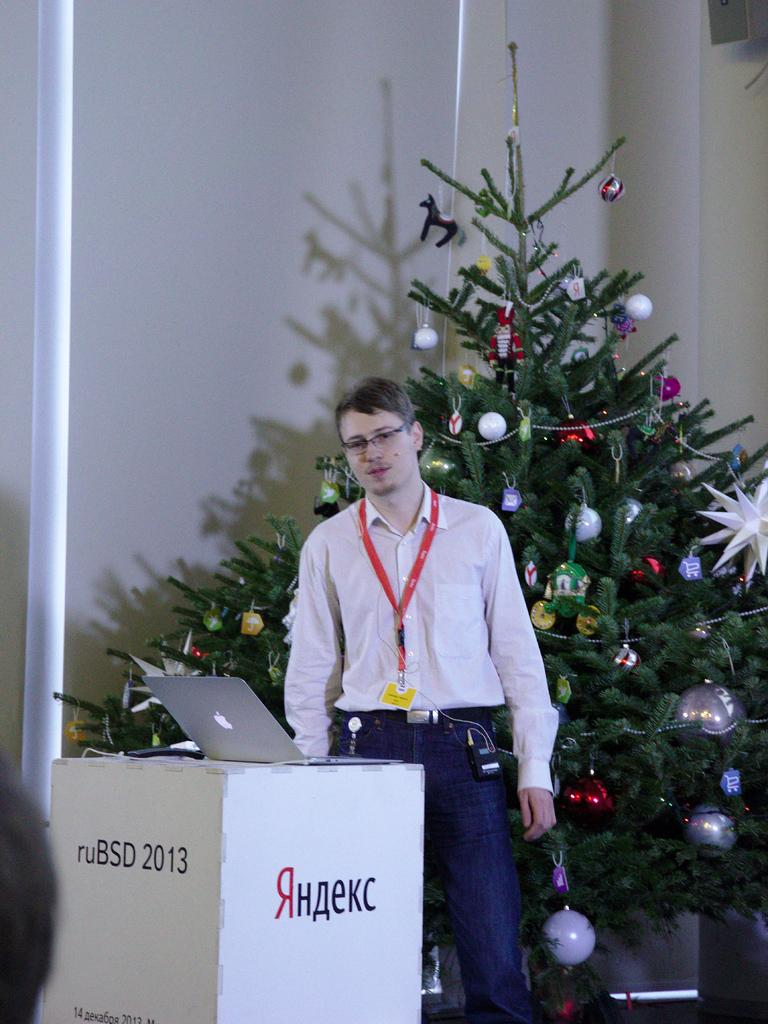<image>
Share a concise interpretation of the image provided. A man stands in front of a podium that says ruBSD 2013 on it. 